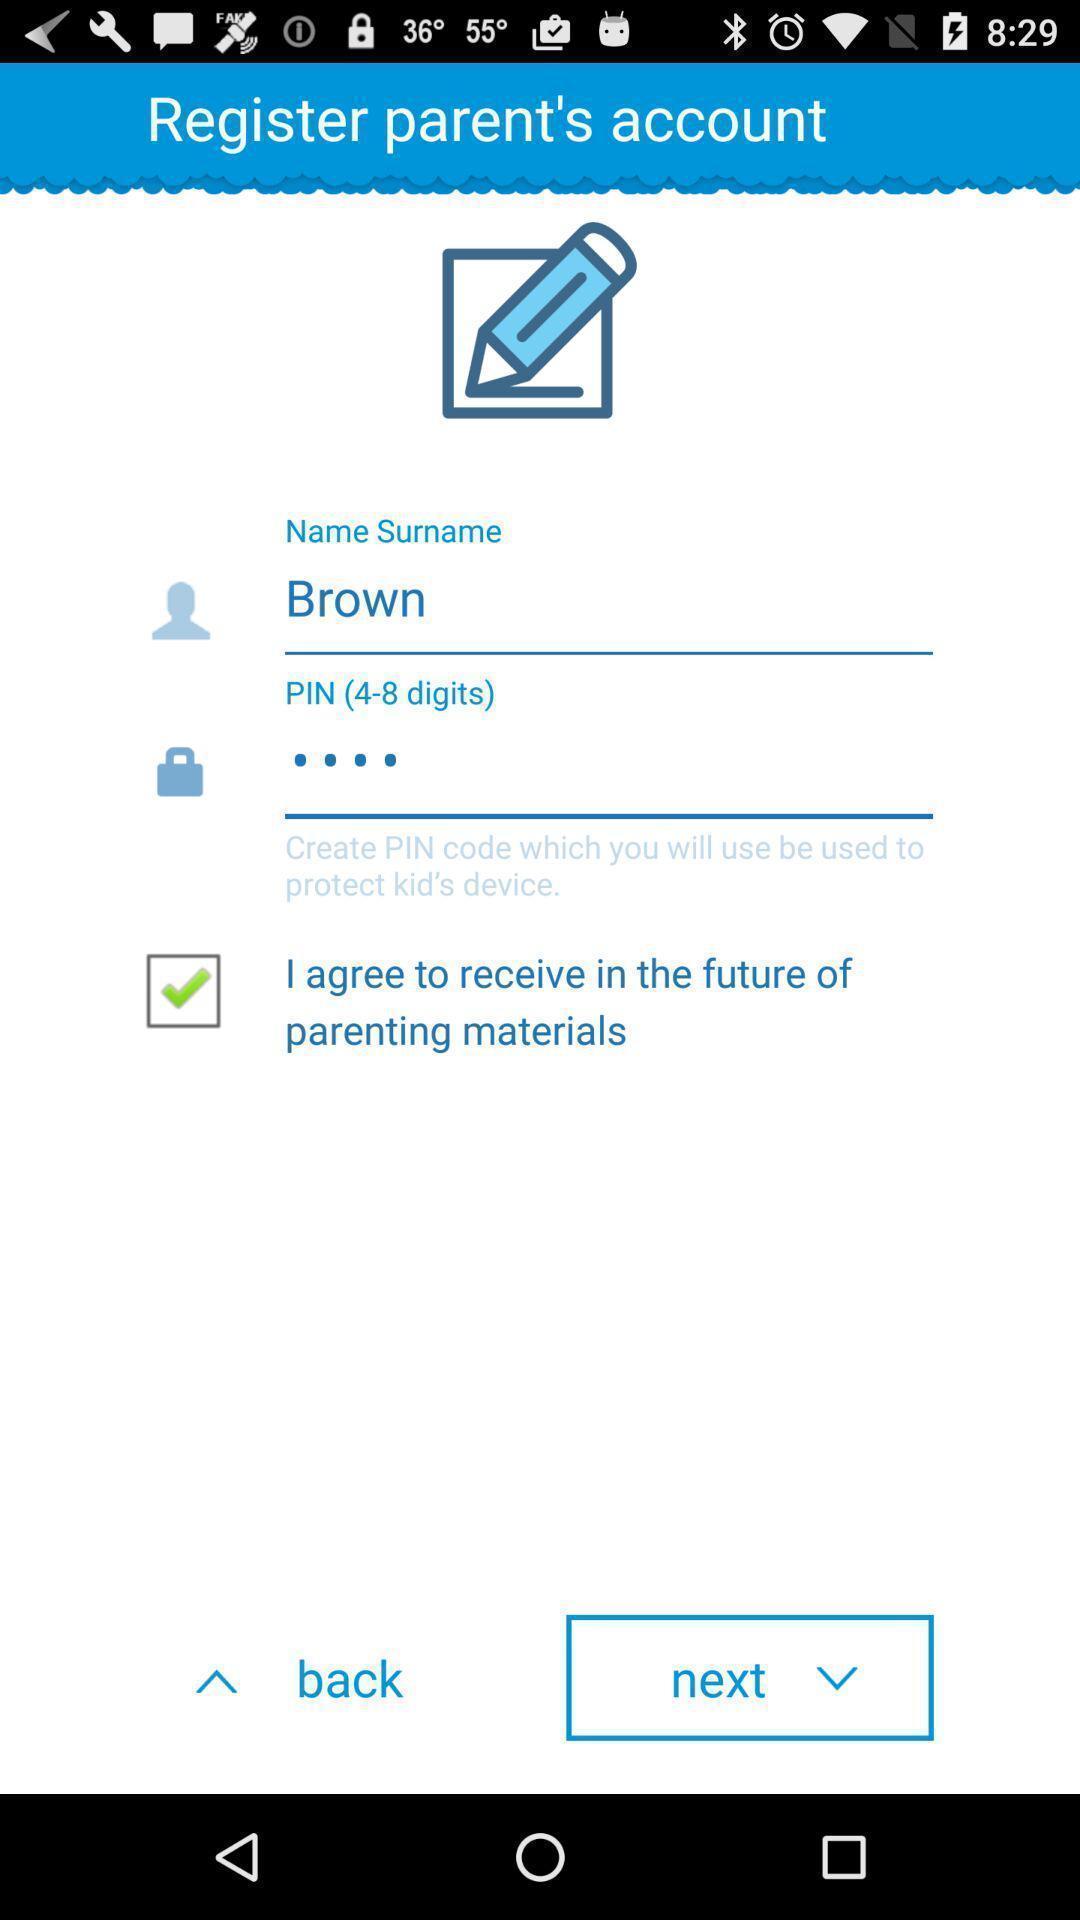Please provide a description for this image. Screen displaying user information in a registration page. 